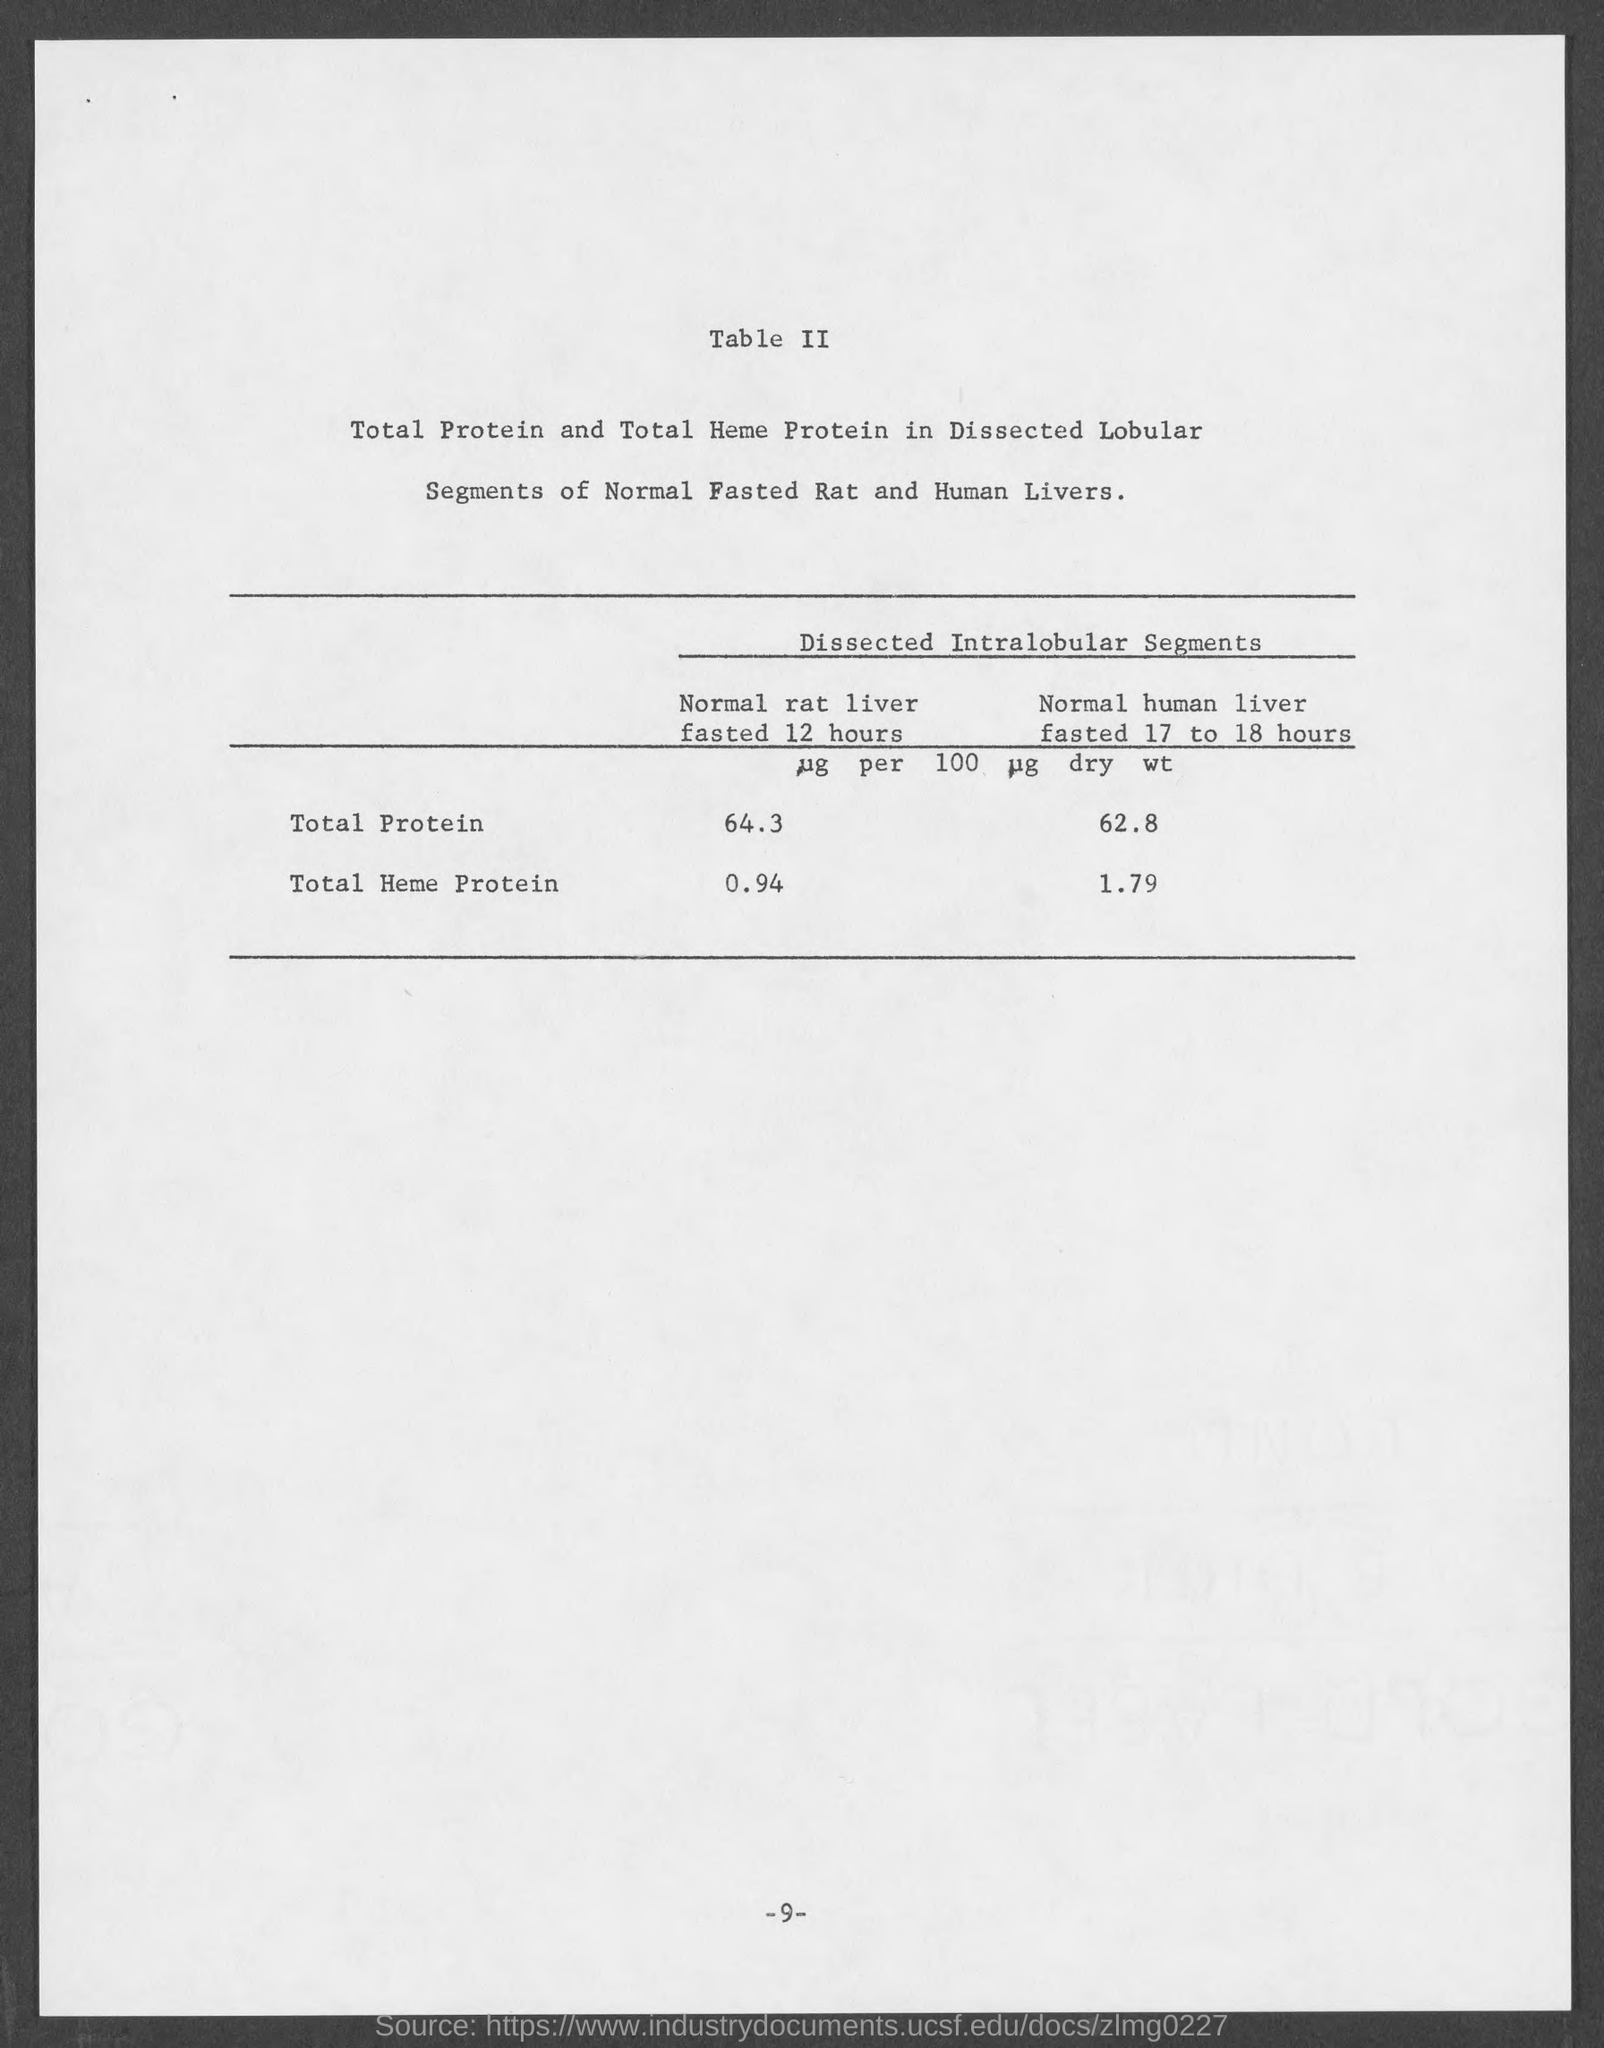Mention a couple of crucial points in this snapshot. The total protein in a normal human liver that has been fasted for 17 to 18 hours is 62.8 micrograms. The page number at the bottom of the page is 9. The total amount of protein in a normal rat liver that has been fasted for 12 hours is 64.3 micrograms. The total amount of heme protein in a normal human liver that has been fasted for 17 to 18 hours is 1.79. The total amount of heme protein in the liver of a normal fasted rat for 12 hours is 0.94. 